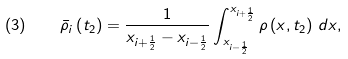Convert formula to latex. <formula><loc_0><loc_0><loc_500><loc_500>( 3 ) \quad { \bar { \rho } } _ { i } \left ( t _ { 2 } \right ) = { \frac { 1 } { x _ { i + { \frac { 1 } { 2 } } } - x _ { i - { \frac { 1 } { 2 } } } } } \int _ { x _ { i - { \frac { 1 } { 2 } } } } ^ { x _ { i + { \frac { 1 } { 2 } } } } \rho \left ( x , t _ { 2 } \right ) \, d x ,</formula> 